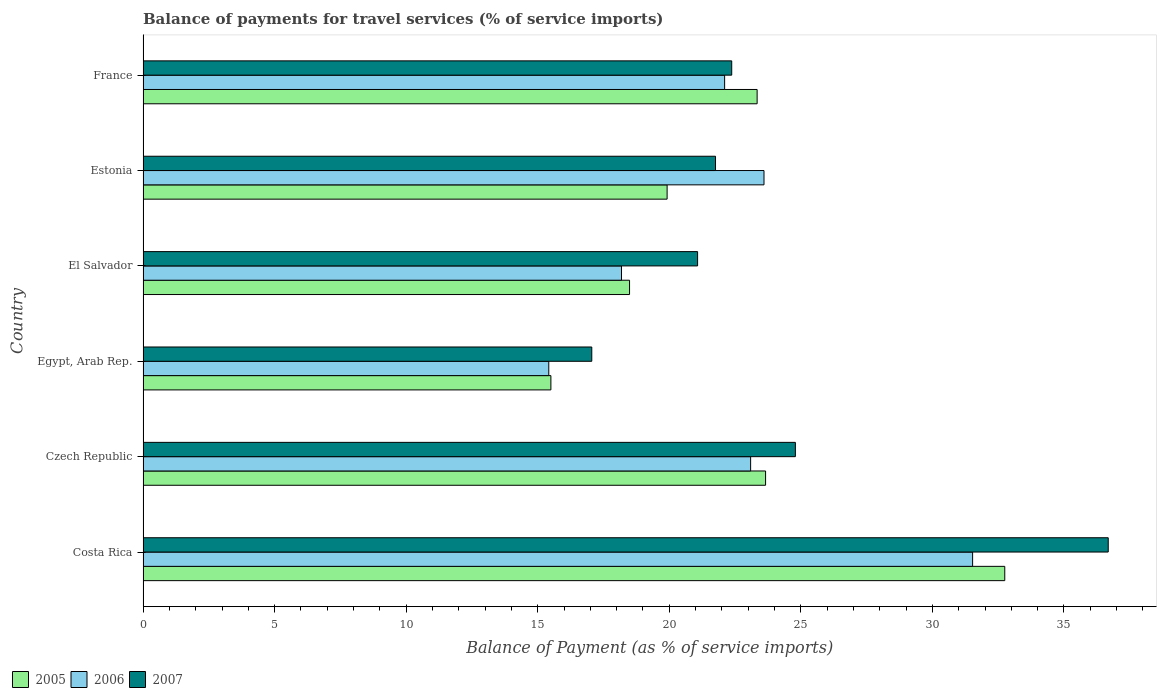How many different coloured bars are there?
Give a very brief answer. 3. How many groups of bars are there?
Ensure brevity in your answer.  6. Are the number of bars per tick equal to the number of legend labels?
Your answer should be compact. Yes. Are the number of bars on each tick of the Y-axis equal?
Make the answer very short. Yes. How many bars are there on the 4th tick from the bottom?
Your response must be concise. 3. What is the balance of payments for travel services in 2005 in France?
Provide a succinct answer. 23.34. Across all countries, what is the maximum balance of payments for travel services in 2005?
Ensure brevity in your answer.  32.75. Across all countries, what is the minimum balance of payments for travel services in 2005?
Offer a very short reply. 15.5. In which country was the balance of payments for travel services in 2006 maximum?
Your answer should be very brief. Costa Rica. In which country was the balance of payments for travel services in 2006 minimum?
Your answer should be compact. Egypt, Arab Rep. What is the total balance of payments for travel services in 2005 in the graph?
Give a very brief answer. 133.65. What is the difference between the balance of payments for travel services in 2005 in Egypt, Arab Rep. and that in El Salvador?
Provide a short and direct response. -2.99. What is the difference between the balance of payments for travel services in 2006 in Czech Republic and the balance of payments for travel services in 2005 in France?
Offer a terse response. -0.25. What is the average balance of payments for travel services in 2005 per country?
Give a very brief answer. 22.28. What is the difference between the balance of payments for travel services in 2006 and balance of payments for travel services in 2007 in Czech Republic?
Make the answer very short. -1.7. What is the ratio of the balance of payments for travel services in 2006 in Costa Rica to that in Egypt, Arab Rep.?
Your response must be concise. 2.04. Is the balance of payments for travel services in 2005 in Costa Rica less than that in Egypt, Arab Rep.?
Provide a succinct answer. No. Is the difference between the balance of payments for travel services in 2006 in Egypt, Arab Rep. and France greater than the difference between the balance of payments for travel services in 2007 in Egypt, Arab Rep. and France?
Your response must be concise. No. What is the difference between the highest and the second highest balance of payments for travel services in 2007?
Your answer should be very brief. 11.89. What is the difference between the highest and the lowest balance of payments for travel services in 2006?
Provide a succinct answer. 16.11. Is the sum of the balance of payments for travel services in 2006 in El Salvador and Estonia greater than the maximum balance of payments for travel services in 2007 across all countries?
Your answer should be compact. Yes. What does the 2nd bar from the top in Estonia represents?
Keep it short and to the point. 2006. Is it the case that in every country, the sum of the balance of payments for travel services in 2006 and balance of payments for travel services in 2005 is greater than the balance of payments for travel services in 2007?
Provide a short and direct response. Yes. How many countries are there in the graph?
Your answer should be compact. 6. Does the graph contain grids?
Your answer should be compact. No. How are the legend labels stacked?
Ensure brevity in your answer.  Horizontal. What is the title of the graph?
Your answer should be very brief. Balance of payments for travel services (% of service imports). Does "2001" appear as one of the legend labels in the graph?
Provide a short and direct response. No. What is the label or title of the X-axis?
Ensure brevity in your answer.  Balance of Payment (as % of service imports). What is the Balance of Payment (as % of service imports) in 2005 in Costa Rica?
Give a very brief answer. 32.75. What is the Balance of Payment (as % of service imports) of 2006 in Costa Rica?
Keep it short and to the point. 31.53. What is the Balance of Payment (as % of service imports) in 2007 in Costa Rica?
Make the answer very short. 36.68. What is the Balance of Payment (as % of service imports) in 2005 in Czech Republic?
Your answer should be compact. 23.66. What is the Balance of Payment (as % of service imports) in 2006 in Czech Republic?
Provide a short and direct response. 23.09. What is the Balance of Payment (as % of service imports) in 2007 in Czech Republic?
Keep it short and to the point. 24.79. What is the Balance of Payment (as % of service imports) in 2005 in Egypt, Arab Rep.?
Provide a short and direct response. 15.5. What is the Balance of Payment (as % of service imports) of 2006 in Egypt, Arab Rep.?
Offer a terse response. 15.42. What is the Balance of Payment (as % of service imports) of 2007 in Egypt, Arab Rep.?
Give a very brief answer. 17.05. What is the Balance of Payment (as % of service imports) in 2005 in El Salvador?
Ensure brevity in your answer.  18.49. What is the Balance of Payment (as % of service imports) in 2006 in El Salvador?
Make the answer very short. 18.18. What is the Balance of Payment (as % of service imports) of 2007 in El Salvador?
Give a very brief answer. 21.08. What is the Balance of Payment (as % of service imports) of 2005 in Estonia?
Give a very brief answer. 19.92. What is the Balance of Payment (as % of service imports) of 2006 in Estonia?
Give a very brief answer. 23.6. What is the Balance of Payment (as % of service imports) of 2007 in Estonia?
Keep it short and to the point. 21.76. What is the Balance of Payment (as % of service imports) of 2005 in France?
Offer a very short reply. 23.34. What is the Balance of Payment (as % of service imports) of 2006 in France?
Keep it short and to the point. 22.1. What is the Balance of Payment (as % of service imports) in 2007 in France?
Offer a terse response. 22.37. Across all countries, what is the maximum Balance of Payment (as % of service imports) in 2005?
Your answer should be compact. 32.75. Across all countries, what is the maximum Balance of Payment (as % of service imports) of 2006?
Offer a terse response. 31.53. Across all countries, what is the maximum Balance of Payment (as % of service imports) in 2007?
Keep it short and to the point. 36.68. Across all countries, what is the minimum Balance of Payment (as % of service imports) of 2005?
Your answer should be very brief. 15.5. Across all countries, what is the minimum Balance of Payment (as % of service imports) of 2006?
Provide a short and direct response. 15.42. Across all countries, what is the minimum Balance of Payment (as % of service imports) in 2007?
Provide a short and direct response. 17.05. What is the total Balance of Payment (as % of service imports) of 2005 in the graph?
Ensure brevity in your answer.  133.65. What is the total Balance of Payment (as % of service imports) in 2006 in the graph?
Provide a short and direct response. 133.92. What is the total Balance of Payment (as % of service imports) of 2007 in the graph?
Offer a very short reply. 143.73. What is the difference between the Balance of Payment (as % of service imports) of 2005 in Costa Rica and that in Czech Republic?
Your answer should be very brief. 9.09. What is the difference between the Balance of Payment (as % of service imports) in 2006 in Costa Rica and that in Czech Republic?
Offer a very short reply. 8.44. What is the difference between the Balance of Payment (as % of service imports) of 2007 in Costa Rica and that in Czech Republic?
Offer a very short reply. 11.89. What is the difference between the Balance of Payment (as % of service imports) of 2005 in Costa Rica and that in Egypt, Arab Rep.?
Offer a very short reply. 17.25. What is the difference between the Balance of Payment (as % of service imports) of 2006 in Costa Rica and that in Egypt, Arab Rep.?
Ensure brevity in your answer.  16.11. What is the difference between the Balance of Payment (as % of service imports) in 2007 in Costa Rica and that in Egypt, Arab Rep.?
Give a very brief answer. 19.63. What is the difference between the Balance of Payment (as % of service imports) in 2005 in Costa Rica and that in El Salvador?
Offer a very short reply. 14.26. What is the difference between the Balance of Payment (as % of service imports) in 2006 in Costa Rica and that in El Salvador?
Provide a short and direct response. 13.34. What is the difference between the Balance of Payment (as % of service imports) of 2007 in Costa Rica and that in El Salvador?
Keep it short and to the point. 15.61. What is the difference between the Balance of Payment (as % of service imports) in 2005 in Costa Rica and that in Estonia?
Offer a terse response. 12.83. What is the difference between the Balance of Payment (as % of service imports) in 2006 in Costa Rica and that in Estonia?
Give a very brief answer. 7.93. What is the difference between the Balance of Payment (as % of service imports) of 2007 in Costa Rica and that in Estonia?
Keep it short and to the point. 14.93. What is the difference between the Balance of Payment (as % of service imports) of 2005 in Costa Rica and that in France?
Provide a succinct answer. 9.41. What is the difference between the Balance of Payment (as % of service imports) of 2006 in Costa Rica and that in France?
Your answer should be very brief. 9.42. What is the difference between the Balance of Payment (as % of service imports) of 2007 in Costa Rica and that in France?
Provide a short and direct response. 14.31. What is the difference between the Balance of Payment (as % of service imports) of 2005 in Czech Republic and that in Egypt, Arab Rep.?
Your answer should be compact. 8.16. What is the difference between the Balance of Payment (as % of service imports) of 2006 in Czech Republic and that in Egypt, Arab Rep.?
Offer a very short reply. 7.67. What is the difference between the Balance of Payment (as % of service imports) in 2007 in Czech Republic and that in Egypt, Arab Rep.?
Keep it short and to the point. 7.74. What is the difference between the Balance of Payment (as % of service imports) in 2005 in Czech Republic and that in El Salvador?
Keep it short and to the point. 5.17. What is the difference between the Balance of Payment (as % of service imports) in 2006 in Czech Republic and that in El Salvador?
Your answer should be compact. 4.91. What is the difference between the Balance of Payment (as % of service imports) of 2007 in Czech Republic and that in El Salvador?
Offer a terse response. 3.72. What is the difference between the Balance of Payment (as % of service imports) in 2005 in Czech Republic and that in Estonia?
Offer a terse response. 3.74. What is the difference between the Balance of Payment (as % of service imports) in 2006 in Czech Republic and that in Estonia?
Give a very brief answer. -0.51. What is the difference between the Balance of Payment (as % of service imports) in 2007 in Czech Republic and that in Estonia?
Offer a very short reply. 3.04. What is the difference between the Balance of Payment (as % of service imports) of 2005 in Czech Republic and that in France?
Keep it short and to the point. 0.32. What is the difference between the Balance of Payment (as % of service imports) of 2007 in Czech Republic and that in France?
Give a very brief answer. 2.42. What is the difference between the Balance of Payment (as % of service imports) in 2005 in Egypt, Arab Rep. and that in El Salvador?
Keep it short and to the point. -2.99. What is the difference between the Balance of Payment (as % of service imports) in 2006 in Egypt, Arab Rep. and that in El Salvador?
Provide a succinct answer. -2.76. What is the difference between the Balance of Payment (as % of service imports) of 2007 in Egypt, Arab Rep. and that in El Salvador?
Your answer should be compact. -4.02. What is the difference between the Balance of Payment (as % of service imports) in 2005 in Egypt, Arab Rep. and that in Estonia?
Make the answer very short. -4.42. What is the difference between the Balance of Payment (as % of service imports) of 2006 in Egypt, Arab Rep. and that in Estonia?
Provide a succinct answer. -8.18. What is the difference between the Balance of Payment (as % of service imports) of 2007 in Egypt, Arab Rep. and that in Estonia?
Your response must be concise. -4.7. What is the difference between the Balance of Payment (as % of service imports) of 2005 in Egypt, Arab Rep. and that in France?
Your response must be concise. -7.84. What is the difference between the Balance of Payment (as % of service imports) in 2006 in Egypt, Arab Rep. and that in France?
Your answer should be compact. -6.68. What is the difference between the Balance of Payment (as % of service imports) of 2007 in Egypt, Arab Rep. and that in France?
Provide a short and direct response. -5.32. What is the difference between the Balance of Payment (as % of service imports) of 2005 in El Salvador and that in Estonia?
Your response must be concise. -1.43. What is the difference between the Balance of Payment (as % of service imports) of 2006 in El Salvador and that in Estonia?
Offer a terse response. -5.42. What is the difference between the Balance of Payment (as % of service imports) of 2007 in El Salvador and that in Estonia?
Offer a very short reply. -0.68. What is the difference between the Balance of Payment (as % of service imports) of 2005 in El Salvador and that in France?
Keep it short and to the point. -4.85. What is the difference between the Balance of Payment (as % of service imports) of 2006 in El Salvador and that in France?
Keep it short and to the point. -3.92. What is the difference between the Balance of Payment (as % of service imports) of 2007 in El Salvador and that in France?
Your answer should be very brief. -1.3. What is the difference between the Balance of Payment (as % of service imports) of 2005 in Estonia and that in France?
Your answer should be very brief. -3.42. What is the difference between the Balance of Payment (as % of service imports) in 2006 in Estonia and that in France?
Keep it short and to the point. 1.5. What is the difference between the Balance of Payment (as % of service imports) of 2007 in Estonia and that in France?
Keep it short and to the point. -0.62. What is the difference between the Balance of Payment (as % of service imports) of 2005 in Costa Rica and the Balance of Payment (as % of service imports) of 2006 in Czech Republic?
Your response must be concise. 9.66. What is the difference between the Balance of Payment (as % of service imports) of 2005 in Costa Rica and the Balance of Payment (as % of service imports) of 2007 in Czech Republic?
Give a very brief answer. 7.96. What is the difference between the Balance of Payment (as % of service imports) of 2006 in Costa Rica and the Balance of Payment (as % of service imports) of 2007 in Czech Republic?
Your response must be concise. 6.74. What is the difference between the Balance of Payment (as % of service imports) in 2005 in Costa Rica and the Balance of Payment (as % of service imports) in 2006 in Egypt, Arab Rep.?
Provide a succinct answer. 17.33. What is the difference between the Balance of Payment (as % of service imports) in 2005 in Costa Rica and the Balance of Payment (as % of service imports) in 2007 in Egypt, Arab Rep.?
Your response must be concise. 15.7. What is the difference between the Balance of Payment (as % of service imports) of 2006 in Costa Rica and the Balance of Payment (as % of service imports) of 2007 in Egypt, Arab Rep.?
Offer a very short reply. 14.47. What is the difference between the Balance of Payment (as % of service imports) in 2005 in Costa Rica and the Balance of Payment (as % of service imports) in 2006 in El Salvador?
Provide a short and direct response. 14.57. What is the difference between the Balance of Payment (as % of service imports) of 2005 in Costa Rica and the Balance of Payment (as % of service imports) of 2007 in El Salvador?
Provide a short and direct response. 11.67. What is the difference between the Balance of Payment (as % of service imports) of 2006 in Costa Rica and the Balance of Payment (as % of service imports) of 2007 in El Salvador?
Your answer should be very brief. 10.45. What is the difference between the Balance of Payment (as % of service imports) in 2005 in Costa Rica and the Balance of Payment (as % of service imports) in 2006 in Estonia?
Give a very brief answer. 9.15. What is the difference between the Balance of Payment (as % of service imports) in 2005 in Costa Rica and the Balance of Payment (as % of service imports) in 2007 in Estonia?
Ensure brevity in your answer.  10.99. What is the difference between the Balance of Payment (as % of service imports) of 2006 in Costa Rica and the Balance of Payment (as % of service imports) of 2007 in Estonia?
Make the answer very short. 9.77. What is the difference between the Balance of Payment (as % of service imports) in 2005 in Costa Rica and the Balance of Payment (as % of service imports) in 2006 in France?
Keep it short and to the point. 10.65. What is the difference between the Balance of Payment (as % of service imports) of 2005 in Costa Rica and the Balance of Payment (as % of service imports) of 2007 in France?
Your answer should be compact. 10.38. What is the difference between the Balance of Payment (as % of service imports) in 2006 in Costa Rica and the Balance of Payment (as % of service imports) in 2007 in France?
Your answer should be compact. 9.15. What is the difference between the Balance of Payment (as % of service imports) in 2005 in Czech Republic and the Balance of Payment (as % of service imports) in 2006 in Egypt, Arab Rep.?
Keep it short and to the point. 8.24. What is the difference between the Balance of Payment (as % of service imports) of 2005 in Czech Republic and the Balance of Payment (as % of service imports) of 2007 in Egypt, Arab Rep.?
Give a very brief answer. 6.61. What is the difference between the Balance of Payment (as % of service imports) in 2006 in Czech Republic and the Balance of Payment (as % of service imports) in 2007 in Egypt, Arab Rep.?
Provide a succinct answer. 6.04. What is the difference between the Balance of Payment (as % of service imports) in 2005 in Czech Republic and the Balance of Payment (as % of service imports) in 2006 in El Salvador?
Your answer should be compact. 5.48. What is the difference between the Balance of Payment (as % of service imports) in 2005 in Czech Republic and the Balance of Payment (as % of service imports) in 2007 in El Salvador?
Give a very brief answer. 2.58. What is the difference between the Balance of Payment (as % of service imports) in 2006 in Czech Republic and the Balance of Payment (as % of service imports) in 2007 in El Salvador?
Offer a terse response. 2.02. What is the difference between the Balance of Payment (as % of service imports) in 2005 in Czech Republic and the Balance of Payment (as % of service imports) in 2006 in Estonia?
Your response must be concise. 0.06. What is the difference between the Balance of Payment (as % of service imports) in 2005 in Czech Republic and the Balance of Payment (as % of service imports) in 2007 in Estonia?
Your response must be concise. 1.9. What is the difference between the Balance of Payment (as % of service imports) in 2006 in Czech Republic and the Balance of Payment (as % of service imports) in 2007 in Estonia?
Offer a terse response. 1.33. What is the difference between the Balance of Payment (as % of service imports) in 2005 in Czech Republic and the Balance of Payment (as % of service imports) in 2006 in France?
Your response must be concise. 1.56. What is the difference between the Balance of Payment (as % of service imports) of 2005 in Czech Republic and the Balance of Payment (as % of service imports) of 2007 in France?
Give a very brief answer. 1.29. What is the difference between the Balance of Payment (as % of service imports) of 2006 in Czech Republic and the Balance of Payment (as % of service imports) of 2007 in France?
Offer a very short reply. 0.72. What is the difference between the Balance of Payment (as % of service imports) in 2005 in Egypt, Arab Rep. and the Balance of Payment (as % of service imports) in 2006 in El Salvador?
Provide a short and direct response. -2.68. What is the difference between the Balance of Payment (as % of service imports) of 2005 in Egypt, Arab Rep. and the Balance of Payment (as % of service imports) of 2007 in El Salvador?
Your answer should be very brief. -5.58. What is the difference between the Balance of Payment (as % of service imports) of 2006 in Egypt, Arab Rep. and the Balance of Payment (as % of service imports) of 2007 in El Salvador?
Offer a terse response. -5.66. What is the difference between the Balance of Payment (as % of service imports) of 2005 in Egypt, Arab Rep. and the Balance of Payment (as % of service imports) of 2006 in Estonia?
Your response must be concise. -8.1. What is the difference between the Balance of Payment (as % of service imports) of 2005 in Egypt, Arab Rep. and the Balance of Payment (as % of service imports) of 2007 in Estonia?
Offer a terse response. -6.26. What is the difference between the Balance of Payment (as % of service imports) of 2006 in Egypt, Arab Rep. and the Balance of Payment (as % of service imports) of 2007 in Estonia?
Your answer should be very brief. -6.34. What is the difference between the Balance of Payment (as % of service imports) of 2005 in Egypt, Arab Rep. and the Balance of Payment (as % of service imports) of 2006 in France?
Your response must be concise. -6.6. What is the difference between the Balance of Payment (as % of service imports) in 2005 in Egypt, Arab Rep. and the Balance of Payment (as % of service imports) in 2007 in France?
Give a very brief answer. -6.87. What is the difference between the Balance of Payment (as % of service imports) of 2006 in Egypt, Arab Rep. and the Balance of Payment (as % of service imports) of 2007 in France?
Give a very brief answer. -6.95. What is the difference between the Balance of Payment (as % of service imports) in 2005 in El Salvador and the Balance of Payment (as % of service imports) in 2006 in Estonia?
Offer a very short reply. -5.11. What is the difference between the Balance of Payment (as % of service imports) of 2005 in El Salvador and the Balance of Payment (as % of service imports) of 2007 in Estonia?
Offer a terse response. -3.27. What is the difference between the Balance of Payment (as % of service imports) in 2006 in El Salvador and the Balance of Payment (as % of service imports) in 2007 in Estonia?
Provide a succinct answer. -3.57. What is the difference between the Balance of Payment (as % of service imports) in 2005 in El Salvador and the Balance of Payment (as % of service imports) in 2006 in France?
Provide a short and direct response. -3.61. What is the difference between the Balance of Payment (as % of service imports) of 2005 in El Salvador and the Balance of Payment (as % of service imports) of 2007 in France?
Make the answer very short. -3.88. What is the difference between the Balance of Payment (as % of service imports) of 2006 in El Salvador and the Balance of Payment (as % of service imports) of 2007 in France?
Provide a succinct answer. -4.19. What is the difference between the Balance of Payment (as % of service imports) in 2005 in Estonia and the Balance of Payment (as % of service imports) in 2006 in France?
Make the answer very short. -2.19. What is the difference between the Balance of Payment (as % of service imports) in 2005 in Estonia and the Balance of Payment (as % of service imports) in 2007 in France?
Keep it short and to the point. -2.46. What is the difference between the Balance of Payment (as % of service imports) of 2006 in Estonia and the Balance of Payment (as % of service imports) of 2007 in France?
Make the answer very short. 1.23. What is the average Balance of Payment (as % of service imports) of 2005 per country?
Make the answer very short. 22.28. What is the average Balance of Payment (as % of service imports) in 2006 per country?
Provide a succinct answer. 22.32. What is the average Balance of Payment (as % of service imports) of 2007 per country?
Provide a short and direct response. 23.96. What is the difference between the Balance of Payment (as % of service imports) of 2005 and Balance of Payment (as % of service imports) of 2006 in Costa Rica?
Your response must be concise. 1.22. What is the difference between the Balance of Payment (as % of service imports) in 2005 and Balance of Payment (as % of service imports) in 2007 in Costa Rica?
Your answer should be compact. -3.93. What is the difference between the Balance of Payment (as % of service imports) of 2006 and Balance of Payment (as % of service imports) of 2007 in Costa Rica?
Provide a short and direct response. -5.15. What is the difference between the Balance of Payment (as % of service imports) in 2005 and Balance of Payment (as % of service imports) in 2006 in Czech Republic?
Your answer should be compact. 0.57. What is the difference between the Balance of Payment (as % of service imports) of 2005 and Balance of Payment (as % of service imports) of 2007 in Czech Republic?
Keep it short and to the point. -1.13. What is the difference between the Balance of Payment (as % of service imports) in 2006 and Balance of Payment (as % of service imports) in 2007 in Czech Republic?
Give a very brief answer. -1.7. What is the difference between the Balance of Payment (as % of service imports) of 2005 and Balance of Payment (as % of service imports) of 2006 in Egypt, Arab Rep.?
Provide a short and direct response. 0.08. What is the difference between the Balance of Payment (as % of service imports) in 2005 and Balance of Payment (as % of service imports) in 2007 in Egypt, Arab Rep.?
Provide a short and direct response. -1.55. What is the difference between the Balance of Payment (as % of service imports) of 2006 and Balance of Payment (as % of service imports) of 2007 in Egypt, Arab Rep.?
Your answer should be very brief. -1.63. What is the difference between the Balance of Payment (as % of service imports) of 2005 and Balance of Payment (as % of service imports) of 2006 in El Salvador?
Give a very brief answer. 0.31. What is the difference between the Balance of Payment (as % of service imports) of 2005 and Balance of Payment (as % of service imports) of 2007 in El Salvador?
Keep it short and to the point. -2.59. What is the difference between the Balance of Payment (as % of service imports) of 2006 and Balance of Payment (as % of service imports) of 2007 in El Salvador?
Ensure brevity in your answer.  -2.89. What is the difference between the Balance of Payment (as % of service imports) in 2005 and Balance of Payment (as % of service imports) in 2006 in Estonia?
Make the answer very short. -3.68. What is the difference between the Balance of Payment (as % of service imports) of 2005 and Balance of Payment (as % of service imports) of 2007 in Estonia?
Your response must be concise. -1.84. What is the difference between the Balance of Payment (as % of service imports) in 2006 and Balance of Payment (as % of service imports) in 2007 in Estonia?
Give a very brief answer. 1.84. What is the difference between the Balance of Payment (as % of service imports) in 2005 and Balance of Payment (as % of service imports) in 2006 in France?
Provide a succinct answer. 1.24. What is the difference between the Balance of Payment (as % of service imports) of 2005 and Balance of Payment (as % of service imports) of 2007 in France?
Provide a succinct answer. 0.97. What is the difference between the Balance of Payment (as % of service imports) in 2006 and Balance of Payment (as % of service imports) in 2007 in France?
Your answer should be compact. -0.27. What is the ratio of the Balance of Payment (as % of service imports) in 2005 in Costa Rica to that in Czech Republic?
Offer a terse response. 1.38. What is the ratio of the Balance of Payment (as % of service imports) of 2006 in Costa Rica to that in Czech Republic?
Make the answer very short. 1.37. What is the ratio of the Balance of Payment (as % of service imports) in 2007 in Costa Rica to that in Czech Republic?
Your answer should be very brief. 1.48. What is the ratio of the Balance of Payment (as % of service imports) of 2005 in Costa Rica to that in Egypt, Arab Rep.?
Provide a short and direct response. 2.11. What is the ratio of the Balance of Payment (as % of service imports) of 2006 in Costa Rica to that in Egypt, Arab Rep.?
Offer a very short reply. 2.04. What is the ratio of the Balance of Payment (as % of service imports) in 2007 in Costa Rica to that in Egypt, Arab Rep.?
Offer a very short reply. 2.15. What is the ratio of the Balance of Payment (as % of service imports) of 2005 in Costa Rica to that in El Salvador?
Offer a very short reply. 1.77. What is the ratio of the Balance of Payment (as % of service imports) in 2006 in Costa Rica to that in El Salvador?
Your answer should be very brief. 1.73. What is the ratio of the Balance of Payment (as % of service imports) in 2007 in Costa Rica to that in El Salvador?
Make the answer very short. 1.74. What is the ratio of the Balance of Payment (as % of service imports) in 2005 in Costa Rica to that in Estonia?
Keep it short and to the point. 1.64. What is the ratio of the Balance of Payment (as % of service imports) of 2006 in Costa Rica to that in Estonia?
Make the answer very short. 1.34. What is the ratio of the Balance of Payment (as % of service imports) in 2007 in Costa Rica to that in Estonia?
Keep it short and to the point. 1.69. What is the ratio of the Balance of Payment (as % of service imports) in 2005 in Costa Rica to that in France?
Keep it short and to the point. 1.4. What is the ratio of the Balance of Payment (as % of service imports) of 2006 in Costa Rica to that in France?
Keep it short and to the point. 1.43. What is the ratio of the Balance of Payment (as % of service imports) of 2007 in Costa Rica to that in France?
Your answer should be very brief. 1.64. What is the ratio of the Balance of Payment (as % of service imports) in 2005 in Czech Republic to that in Egypt, Arab Rep.?
Give a very brief answer. 1.53. What is the ratio of the Balance of Payment (as % of service imports) of 2006 in Czech Republic to that in Egypt, Arab Rep.?
Your answer should be compact. 1.5. What is the ratio of the Balance of Payment (as % of service imports) in 2007 in Czech Republic to that in Egypt, Arab Rep.?
Offer a very short reply. 1.45. What is the ratio of the Balance of Payment (as % of service imports) in 2005 in Czech Republic to that in El Salvador?
Give a very brief answer. 1.28. What is the ratio of the Balance of Payment (as % of service imports) in 2006 in Czech Republic to that in El Salvador?
Provide a succinct answer. 1.27. What is the ratio of the Balance of Payment (as % of service imports) in 2007 in Czech Republic to that in El Salvador?
Give a very brief answer. 1.18. What is the ratio of the Balance of Payment (as % of service imports) in 2005 in Czech Republic to that in Estonia?
Offer a terse response. 1.19. What is the ratio of the Balance of Payment (as % of service imports) of 2006 in Czech Republic to that in Estonia?
Offer a terse response. 0.98. What is the ratio of the Balance of Payment (as % of service imports) in 2007 in Czech Republic to that in Estonia?
Your response must be concise. 1.14. What is the ratio of the Balance of Payment (as % of service imports) of 2005 in Czech Republic to that in France?
Provide a short and direct response. 1.01. What is the ratio of the Balance of Payment (as % of service imports) in 2006 in Czech Republic to that in France?
Ensure brevity in your answer.  1.04. What is the ratio of the Balance of Payment (as % of service imports) in 2007 in Czech Republic to that in France?
Your answer should be compact. 1.11. What is the ratio of the Balance of Payment (as % of service imports) in 2005 in Egypt, Arab Rep. to that in El Salvador?
Provide a short and direct response. 0.84. What is the ratio of the Balance of Payment (as % of service imports) of 2006 in Egypt, Arab Rep. to that in El Salvador?
Make the answer very short. 0.85. What is the ratio of the Balance of Payment (as % of service imports) of 2007 in Egypt, Arab Rep. to that in El Salvador?
Offer a terse response. 0.81. What is the ratio of the Balance of Payment (as % of service imports) of 2005 in Egypt, Arab Rep. to that in Estonia?
Your answer should be compact. 0.78. What is the ratio of the Balance of Payment (as % of service imports) in 2006 in Egypt, Arab Rep. to that in Estonia?
Make the answer very short. 0.65. What is the ratio of the Balance of Payment (as % of service imports) of 2007 in Egypt, Arab Rep. to that in Estonia?
Your answer should be very brief. 0.78. What is the ratio of the Balance of Payment (as % of service imports) of 2005 in Egypt, Arab Rep. to that in France?
Provide a succinct answer. 0.66. What is the ratio of the Balance of Payment (as % of service imports) in 2006 in Egypt, Arab Rep. to that in France?
Your answer should be compact. 0.7. What is the ratio of the Balance of Payment (as % of service imports) in 2007 in Egypt, Arab Rep. to that in France?
Your answer should be compact. 0.76. What is the ratio of the Balance of Payment (as % of service imports) in 2005 in El Salvador to that in Estonia?
Your answer should be compact. 0.93. What is the ratio of the Balance of Payment (as % of service imports) of 2006 in El Salvador to that in Estonia?
Make the answer very short. 0.77. What is the ratio of the Balance of Payment (as % of service imports) of 2007 in El Salvador to that in Estonia?
Give a very brief answer. 0.97. What is the ratio of the Balance of Payment (as % of service imports) in 2005 in El Salvador to that in France?
Make the answer very short. 0.79. What is the ratio of the Balance of Payment (as % of service imports) of 2006 in El Salvador to that in France?
Make the answer very short. 0.82. What is the ratio of the Balance of Payment (as % of service imports) of 2007 in El Salvador to that in France?
Your answer should be compact. 0.94. What is the ratio of the Balance of Payment (as % of service imports) of 2005 in Estonia to that in France?
Your response must be concise. 0.85. What is the ratio of the Balance of Payment (as % of service imports) in 2006 in Estonia to that in France?
Give a very brief answer. 1.07. What is the ratio of the Balance of Payment (as % of service imports) in 2007 in Estonia to that in France?
Your response must be concise. 0.97. What is the difference between the highest and the second highest Balance of Payment (as % of service imports) of 2005?
Provide a succinct answer. 9.09. What is the difference between the highest and the second highest Balance of Payment (as % of service imports) in 2006?
Your answer should be compact. 7.93. What is the difference between the highest and the second highest Balance of Payment (as % of service imports) in 2007?
Your answer should be compact. 11.89. What is the difference between the highest and the lowest Balance of Payment (as % of service imports) in 2005?
Give a very brief answer. 17.25. What is the difference between the highest and the lowest Balance of Payment (as % of service imports) in 2006?
Offer a terse response. 16.11. What is the difference between the highest and the lowest Balance of Payment (as % of service imports) of 2007?
Provide a succinct answer. 19.63. 